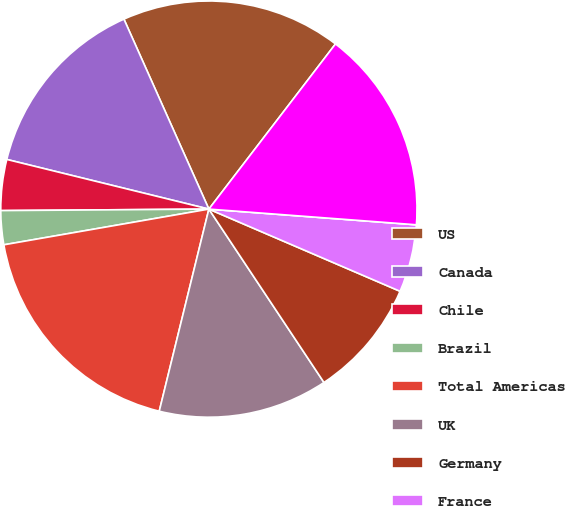Convert chart to OTSL. <chart><loc_0><loc_0><loc_500><loc_500><pie_chart><fcel>US<fcel>Canada<fcel>Chile<fcel>Brazil<fcel>Total Americas<fcel>UK<fcel>Germany<fcel>France<fcel>Netherlands<fcel>Total EMEA<nl><fcel>17.1%<fcel>14.47%<fcel>3.95%<fcel>2.63%<fcel>18.42%<fcel>13.16%<fcel>9.21%<fcel>5.26%<fcel>0.0%<fcel>15.79%<nl></chart> 